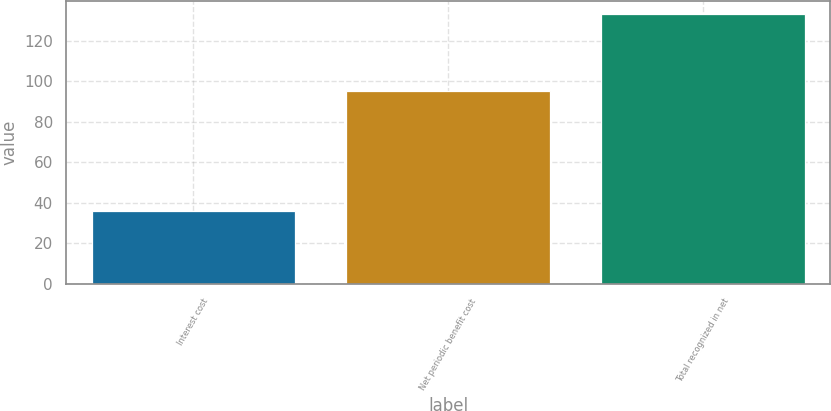Convert chart. <chart><loc_0><loc_0><loc_500><loc_500><bar_chart><fcel>Interest cost<fcel>Net periodic benefit cost<fcel>Total recognized in net<nl><fcel>36<fcel>95<fcel>133<nl></chart> 